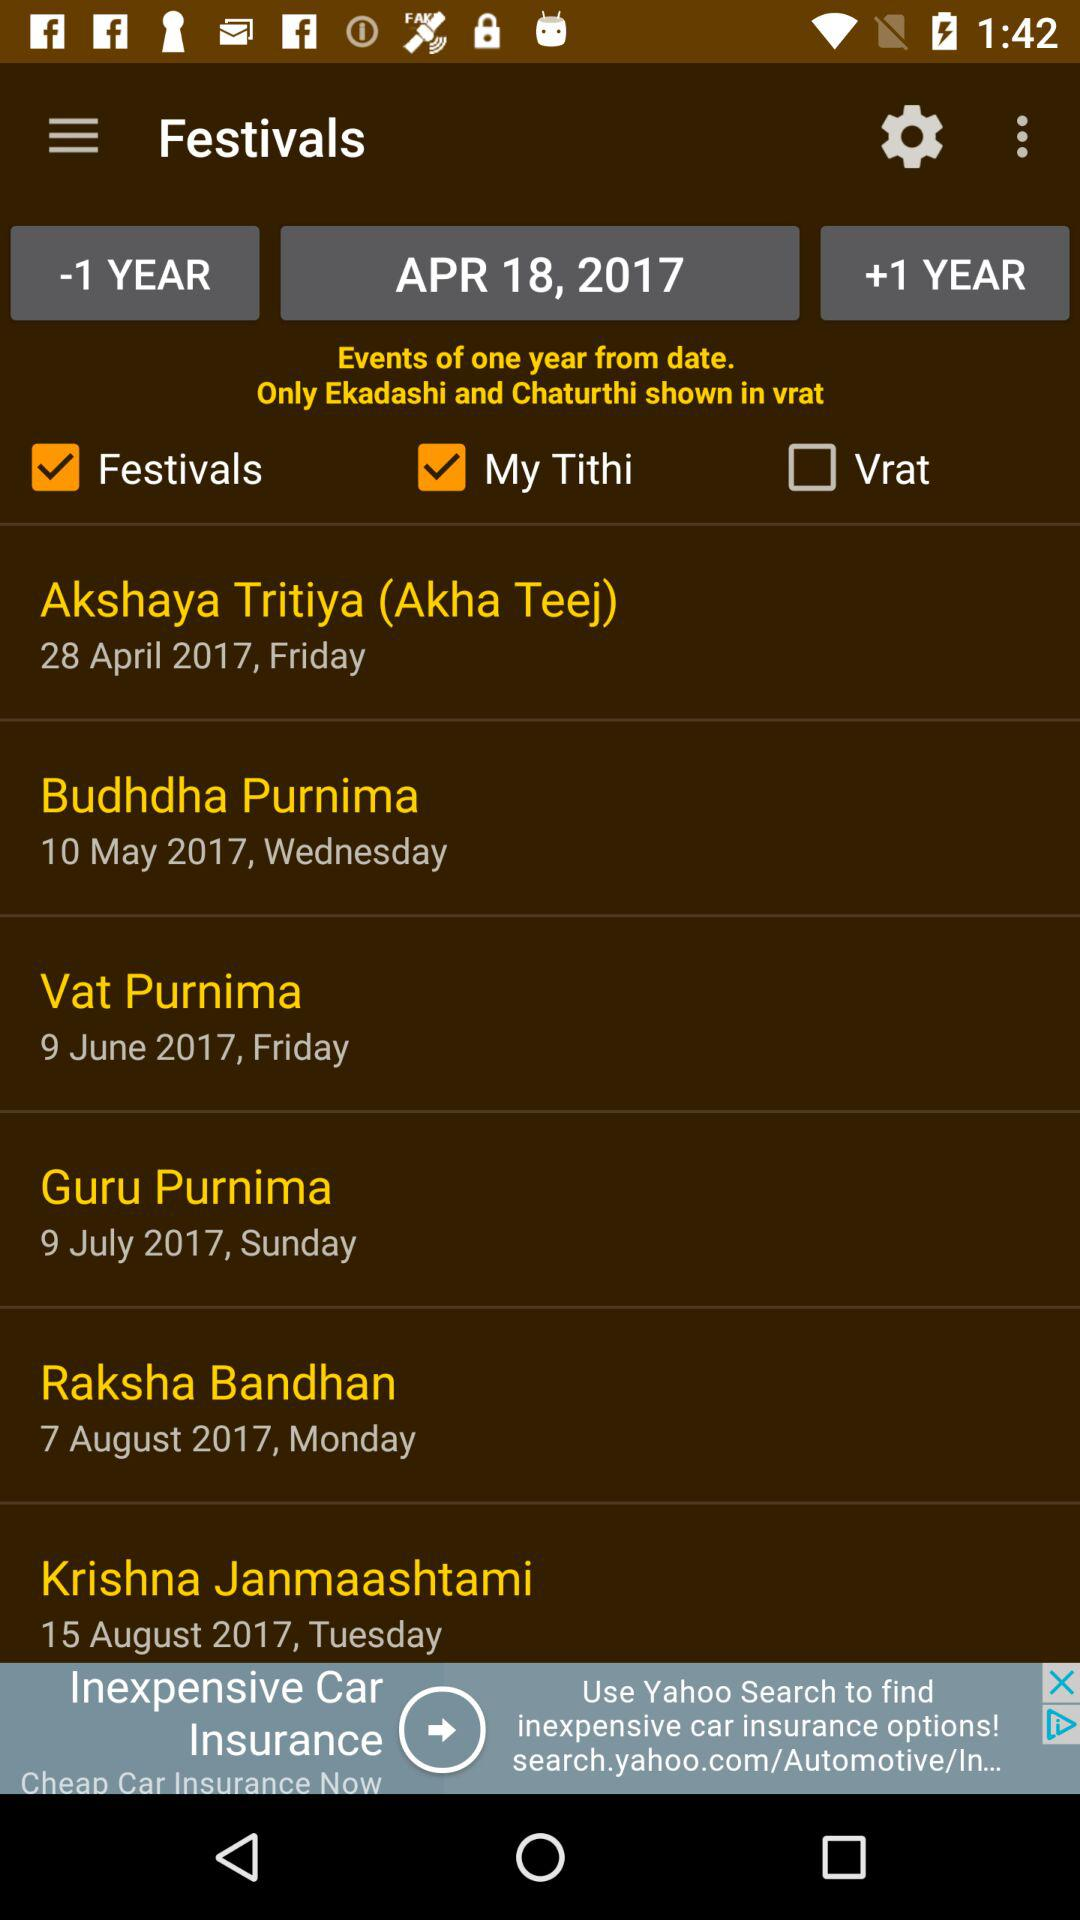What is the status of "Festivals"? The status of "Festivals" is "on". 